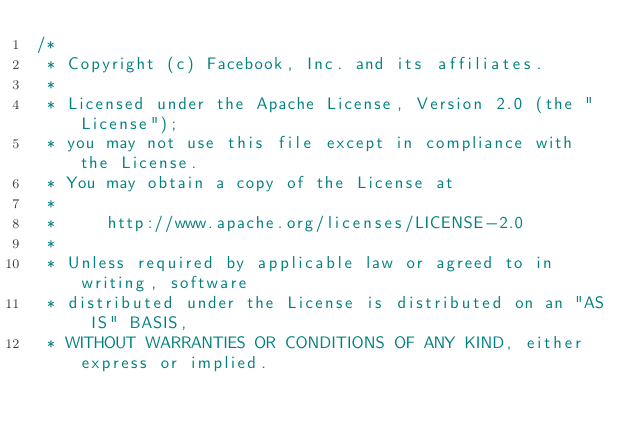<code> <loc_0><loc_0><loc_500><loc_500><_C++_>/*
 * Copyright (c) Facebook, Inc. and its affiliates.
 *
 * Licensed under the Apache License, Version 2.0 (the "License");
 * you may not use this file except in compliance with the License.
 * You may obtain a copy of the License at
 *
 *     http://www.apache.org/licenses/LICENSE-2.0
 *
 * Unless required by applicable law or agreed to in writing, software
 * distributed under the License is distributed on an "AS IS" BASIS,
 * WITHOUT WARRANTIES OR CONDITIONS OF ANY KIND, either express or implied.</code> 